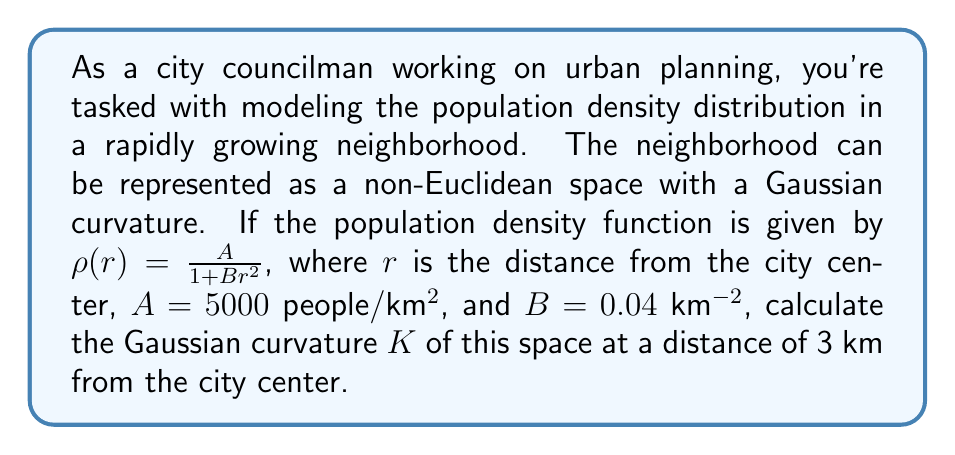Teach me how to tackle this problem. To solve this problem, we'll follow these steps:

1) In a non-Euclidean space, the Gaussian curvature $K$ is related to the population density $\rho(r)$ by the equation:

   $$K(r) = -\frac{1}{\rho(r)} \frac{d^2\rho}{dr^2}$$

2) We start with the given population density function:
   
   $$\rho(r) = \frac{A}{1 + Br^2}$$

3) Calculate the first derivative:
   
   $$\frac{d\rho}{dr} = \frac{-2ABr}{(1 + Br^2)^2}$$

4) Calculate the second derivative:
   
   $$\frac{d^2\rho}{dr^2} = \frac{-2AB(1 + Br^2)^2 + 8AB^2r^2(1 + Br^2)}{(1 + Br^2)^4}$$
   
   $$= \frac{-2AB((1 + Br^2)^2 - 4Br^2(1 + Br^2))}{(1 + Br^2)^4}$$
   
   $$= \frac{-2AB(1 - 2Br^2 + B^2r^4)}{(1 + Br^2)^4}$$

5) Now, substitute this into the curvature equation:

   $$K(r) = -\frac{1}{\rho(r)} \frac{d^2\rho}{dr^2}$$
   
   $$= -\frac{1 + Br^2}{A} \cdot \frac{-2AB(1 - 2Br^2 + B^2r^4)}{(1 + Br^2)^4}$$
   
   $$= \frac{2B(1 - 2Br^2 + B^2r^4)}{(1 + Br^2)^3}$$

6) Now, we can substitute the given values: $A = 5000$, $B = 0.04$, and $r = 3$:

   $$K(3) = \frac{2(0.04)(1 - 2(0.04)(3^2) + (0.04)^2(3^4))}{(1 + 0.04(3^2))^3}$$
   
   $$= \frac{0.08(1 - 0.72 + 0.1296)}{(1 + 0.36)^3}$$
   
   $$= \frac{0.08(0.4096)}{(1.36)^3}$$
   
   $$= \frac{0.032768}{2.515456}$$
   
   $$\approx 0.0130 \text{ km}^{-2}$$
Answer: $0.0130 \text{ km}^{-2}$ 